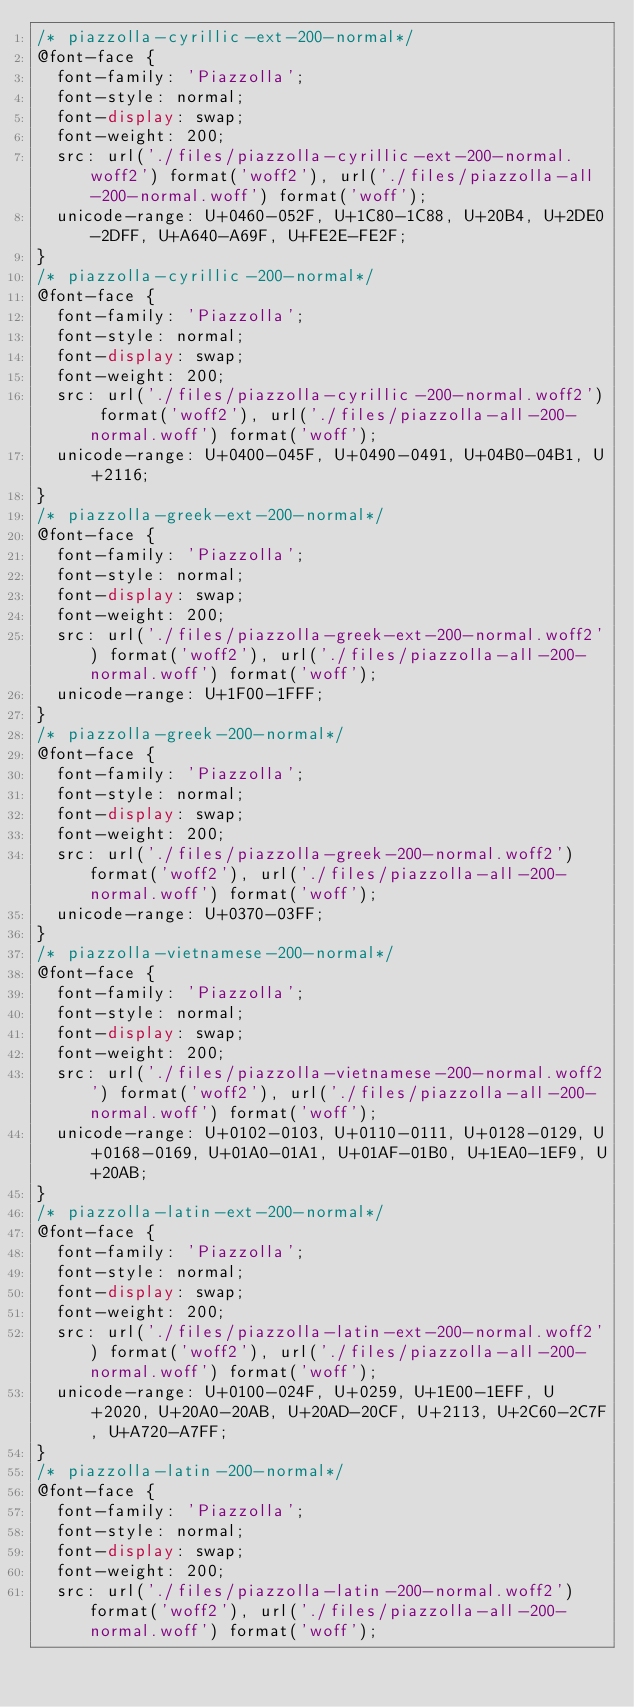Convert code to text. <code><loc_0><loc_0><loc_500><loc_500><_CSS_>/* piazzolla-cyrillic-ext-200-normal*/
@font-face {
  font-family: 'Piazzolla';
  font-style: normal;
  font-display: swap;
  font-weight: 200;
  src: url('./files/piazzolla-cyrillic-ext-200-normal.woff2') format('woff2'), url('./files/piazzolla-all-200-normal.woff') format('woff');
  unicode-range: U+0460-052F, U+1C80-1C88, U+20B4, U+2DE0-2DFF, U+A640-A69F, U+FE2E-FE2F;
}
/* piazzolla-cyrillic-200-normal*/
@font-face {
  font-family: 'Piazzolla';
  font-style: normal;
  font-display: swap;
  font-weight: 200;
  src: url('./files/piazzolla-cyrillic-200-normal.woff2') format('woff2'), url('./files/piazzolla-all-200-normal.woff') format('woff');
  unicode-range: U+0400-045F, U+0490-0491, U+04B0-04B1, U+2116;
}
/* piazzolla-greek-ext-200-normal*/
@font-face {
  font-family: 'Piazzolla';
  font-style: normal;
  font-display: swap;
  font-weight: 200;
  src: url('./files/piazzolla-greek-ext-200-normal.woff2') format('woff2'), url('./files/piazzolla-all-200-normal.woff') format('woff');
  unicode-range: U+1F00-1FFF;
}
/* piazzolla-greek-200-normal*/
@font-face {
  font-family: 'Piazzolla';
  font-style: normal;
  font-display: swap;
  font-weight: 200;
  src: url('./files/piazzolla-greek-200-normal.woff2') format('woff2'), url('./files/piazzolla-all-200-normal.woff') format('woff');
  unicode-range: U+0370-03FF;
}
/* piazzolla-vietnamese-200-normal*/
@font-face {
  font-family: 'Piazzolla';
  font-style: normal;
  font-display: swap;
  font-weight: 200;
  src: url('./files/piazzolla-vietnamese-200-normal.woff2') format('woff2'), url('./files/piazzolla-all-200-normal.woff') format('woff');
  unicode-range: U+0102-0103, U+0110-0111, U+0128-0129, U+0168-0169, U+01A0-01A1, U+01AF-01B0, U+1EA0-1EF9, U+20AB;
}
/* piazzolla-latin-ext-200-normal*/
@font-face {
  font-family: 'Piazzolla';
  font-style: normal;
  font-display: swap;
  font-weight: 200;
  src: url('./files/piazzolla-latin-ext-200-normal.woff2') format('woff2'), url('./files/piazzolla-all-200-normal.woff') format('woff');
  unicode-range: U+0100-024F, U+0259, U+1E00-1EFF, U+2020, U+20A0-20AB, U+20AD-20CF, U+2113, U+2C60-2C7F, U+A720-A7FF;
}
/* piazzolla-latin-200-normal*/
@font-face {
  font-family: 'Piazzolla';
  font-style: normal;
  font-display: swap;
  font-weight: 200;
  src: url('./files/piazzolla-latin-200-normal.woff2') format('woff2'), url('./files/piazzolla-all-200-normal.woff') format('woff');</code> 